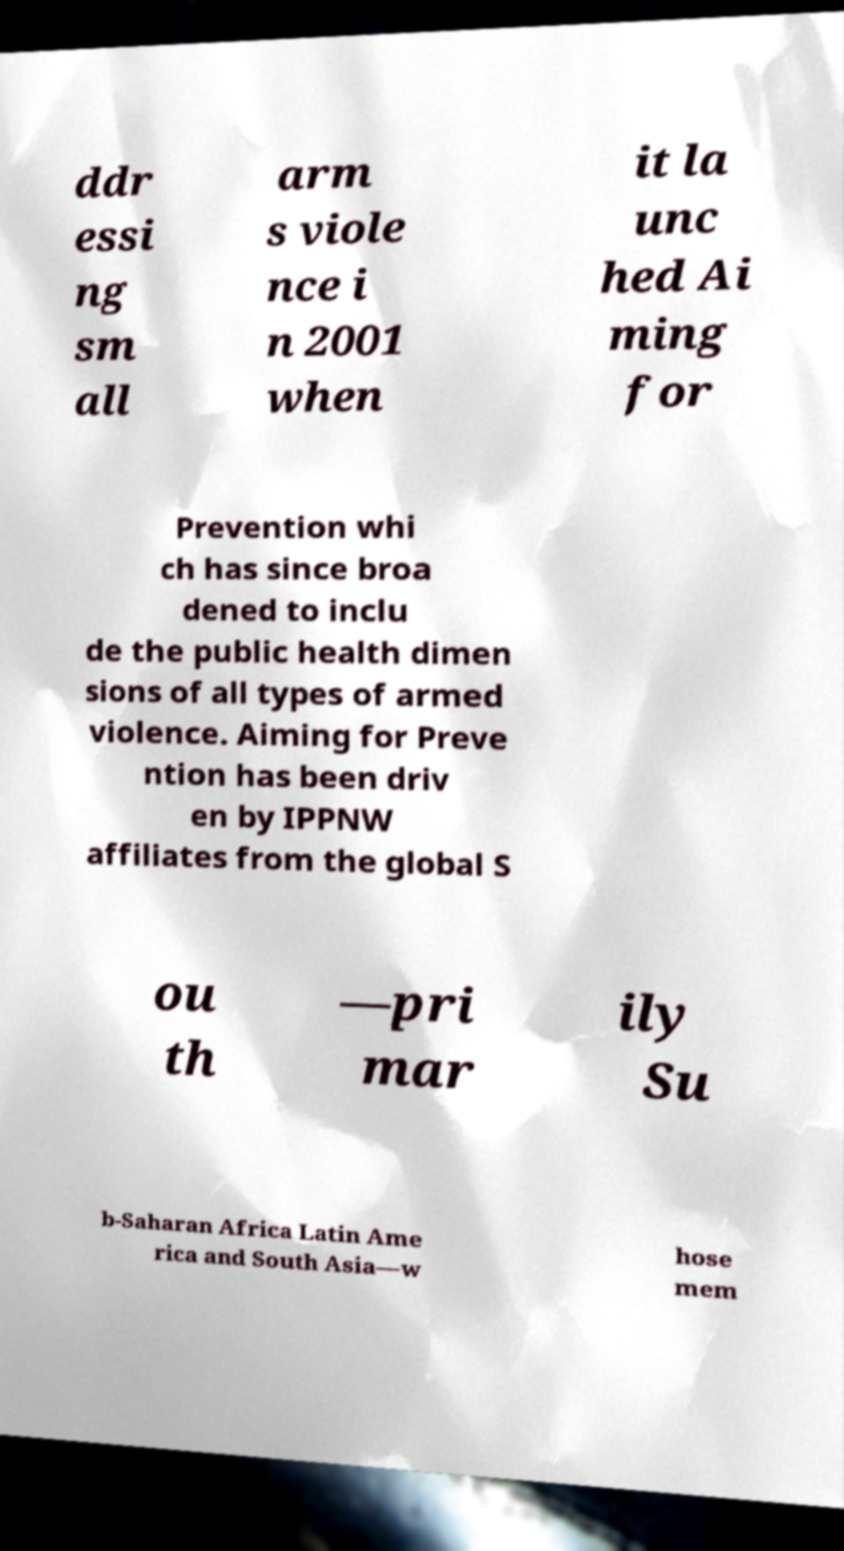I need the written content from this picture converted into text. Can you do that? ddr essi ng sm all arm s viole nce i n 2001 when it la unc hed Ai ming for Prevention whi ch has since broa dened to inclu de the public health dimen sions of all types of armed violence. Aiming for Preve ntion has been driv en by IPPNW affiliates from the global S ou th —pri mar ily Su b-Saharan Africa Latin Ame rica and South Asia—w hose mem 